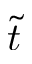<formula> <loc_0><loc_0><loc_500><loc_500>\tilde { t }</formula> 